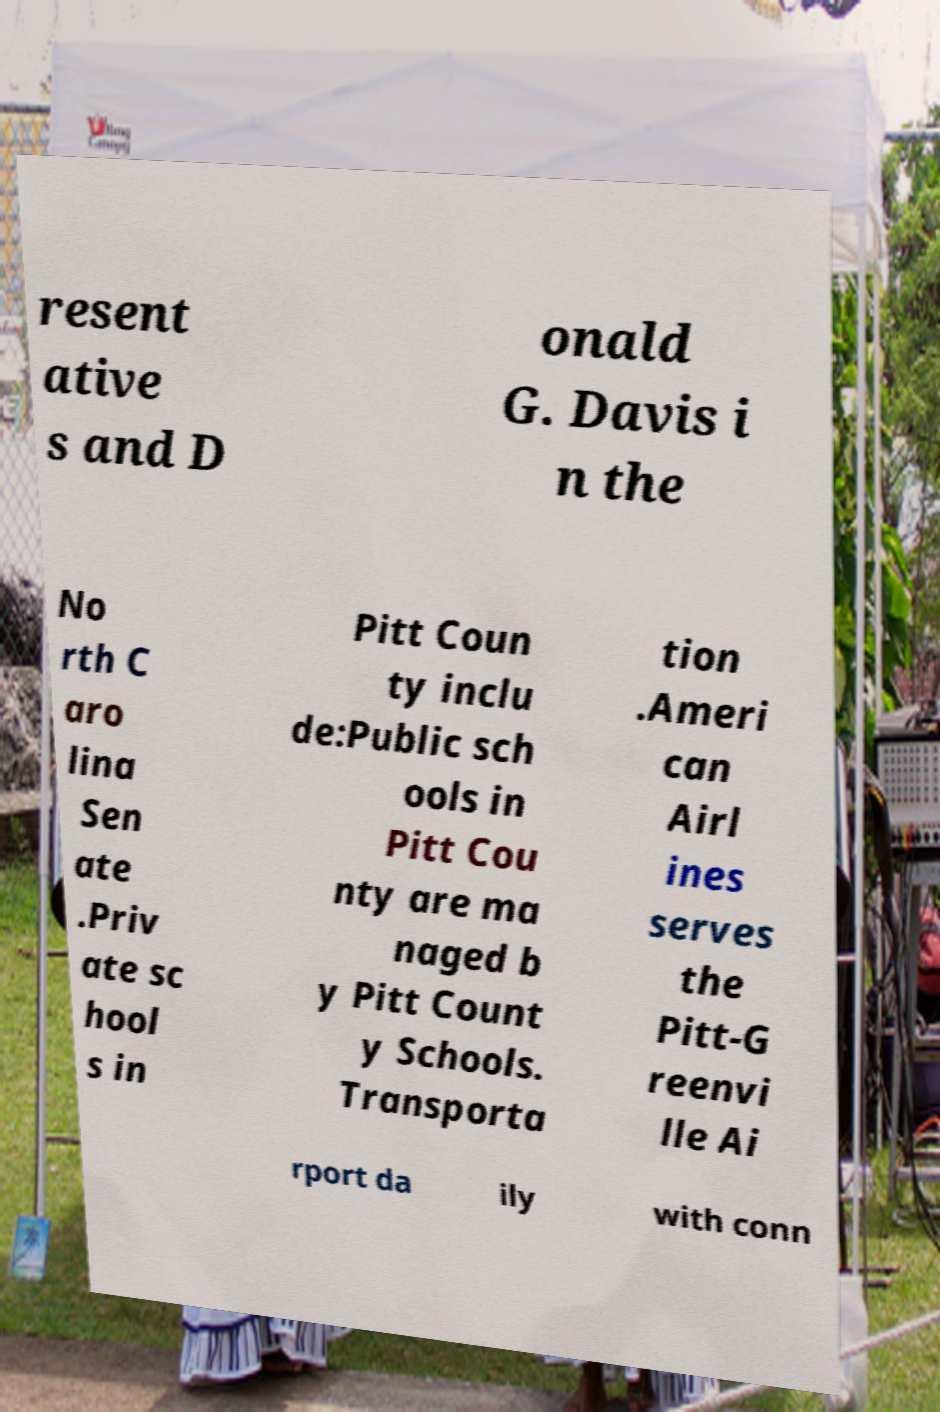For documentation purposes, I need the text within this image transcribed. Could you provide that? resent ative s and D onald G. Davis i n the No rth C aro lina Sen ate .Priv ate sc hool s in Pitt Coun ty inclu de:Public sch ools in Pitt Cou nty are ma naged b y Pitt Count y Schools. Transporta tion .Ameri can Airl ines serves the Pitt-G reenvi lle Ai rport da ily with conn 